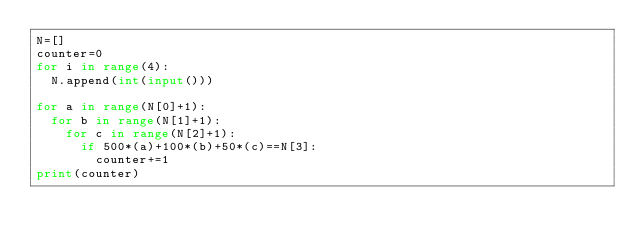Convert code to text. <code><loc_0><loc_0><loc_500><loc_500><_Python_>N=[]
counter=0
for i in range(4):
  N.append(int(input()))

for a in range(N[0]+1):
  for b in range(N[1]+1):
    for c in range(N[2]+1):
      if 500*(a)+100*(b)+50*(c)==N[3]:
        counter+=1
print(counter)</code> 